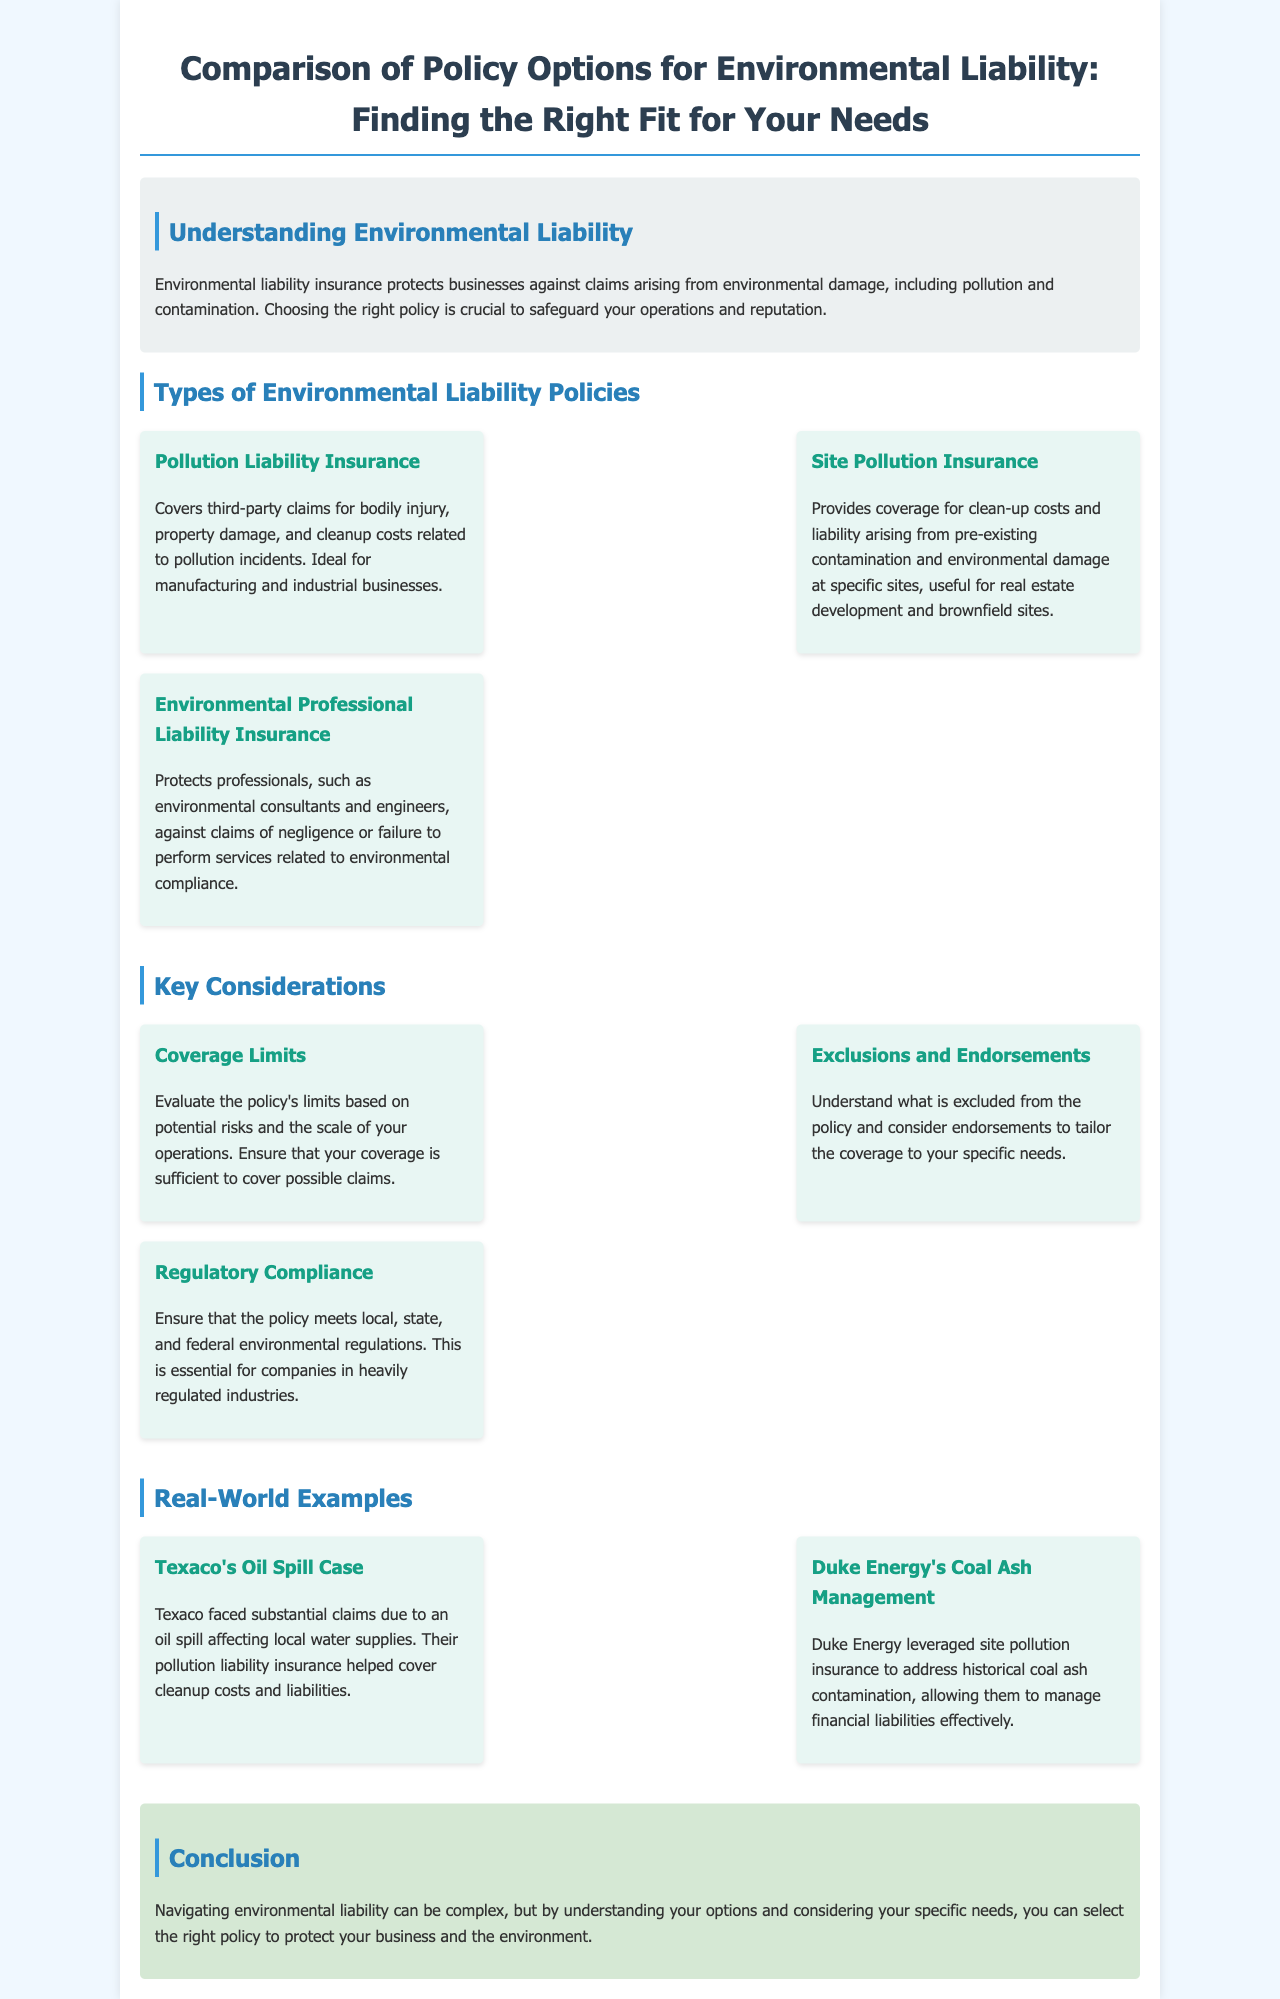What is the title of the brochure? The title is located at the top of the document and is clearly stated, focusing on the comparison of policy options for environmental liability.
Answer: Comparison of Policy Options for Environmental Liability: Finding the Right Fit for Your Needs What type of policy is ideal for manufacturing businesses? The document specifies that the pollution liability insurance is particularly suited for manufacturing and industrial businesses, highlighting its relevance.
Answer: Pollution Liability Insurance What does site pollution insurance cover? The document provides a clear definition, indicating that it covers clean-up costs and liability arising from pre-existing contamination and environmental damage at specific sites.
Answer: Clean-up costs and liability What are two key considerations mentioned in the brochure? The document lists coverage limits and exclusions and endorsements as important considerations, allowing for effective policy selection.
Answer: Coverage limits and exclusions Which case illustrates a company's use of pollution liability insurance? An example in the document describes Texaco's situation, showcasing the application of pollution liability insurance in a real-world context involving substantial claims.
Answer: Texaco's Oil Spill Case 